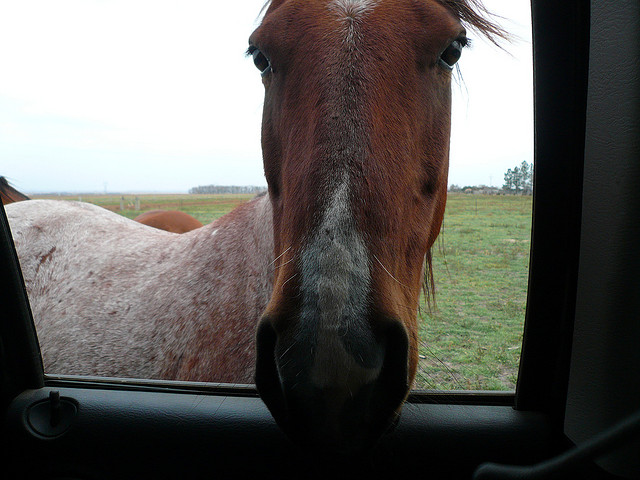<image>What vehicle can be seen outside? I don't know. There can be a horse or a car, but it's also possible that there is no vehicle. What vehicle can be seen outside? There is no vehicle seen outside. 